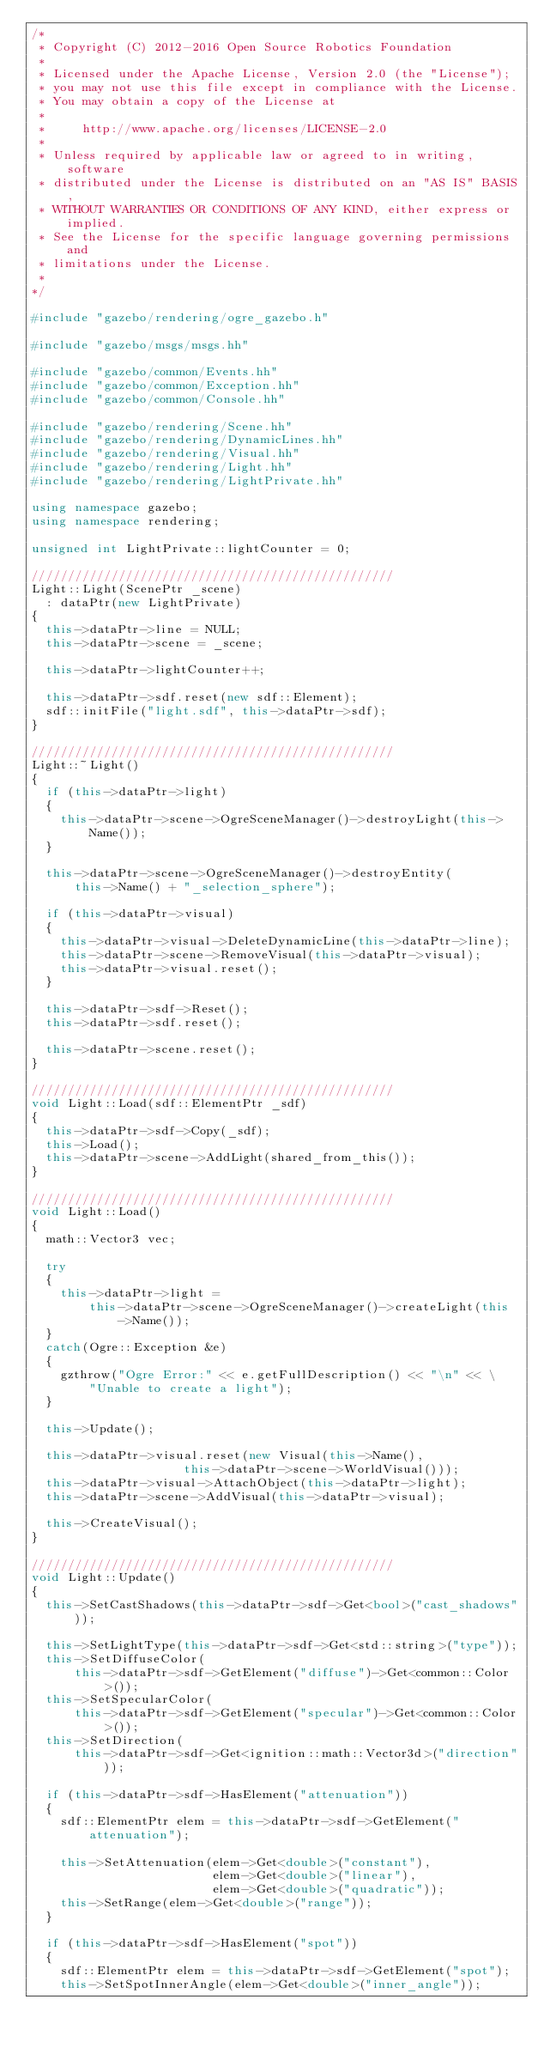Convert code to text. <code><loc_0><loc_0><loc_500><loc_500><_C++_>/*
 * Copyright (C) 2012-2016 Open Source Robotics Foundation
 *
 * Licensed under the Apache License, Version 2.0 (the "License");
 * you may not use this file except in compliance with the License.
 * You may obtain a copy of the License at
 *
 *     http://www.apache.org/licenses/LICENSE-2.0
 *
 * Unless required by applicable law or agreed to in writing, software
 * distributed under the License is distributed on an "AS IS" BASIS,
 * WITHOUT WARRANTIES OR CONDITIONS OF ANY KIND, either express or implied.
 * See the License for the specific language governing permissions and
 * limitations under the License.
 *
*/

#include "gazebo/rendering/ogre_gazebo.h"

#include "gazebo/msgs/msgs.hh"

#include "gazebo/common/Events.hh"
#include "gazebo/common/Exception.hh"
#include "gazebo/common/Console.hh"

#include "gazebo/rendering/Scene.hh"
#include "gazebo/rendering/DynamicLines.hh"
#include "gazebo/rendering/Visual.hh"
#include "gazebo/rendering/Light.hh"
#include "gazebo/rendering/LightPrivate.hh"

using namespace gazebo;
using namespace rendering;

unsigned int LightPrivate::lightCounter = 0;

//////////////////////////////////////////////////
Light::Light(ScenePtr _scene)
  : dataPtr(new LightPrivate)
{
  this->dataPtr->line = NULL;
  this->dataPtr->scene = _scene;

  this->dataPtr->lightCounter++;

  this->dataPtr->sdf.reset(new sdf::Element);
  sdf::initFile("light.sdf", this->dataPtr->sdf);
}

//////////////////////////////////////////////////
Light::~Light()
{
  if (this->dataPtr->light)
  {
    this->dataPtr->scene->OgreSceneManager()->destroyLight(this->Name());
  }

  this->dataPtr->scene->OgreSceneManager()->destroyEntity(
      this->Name() + "_selection_sphere");

  if (this->dataPtr->visual)
  {
    this->dataPtr->visual->DeleteDynamicLine(this->dataPtr->line);
    this->dataPtr->scene->RemoveVisual(this->dataPtr->visual);
    this->dataPtr->visual.reset();
  }

  this->dataPtr->sdf->Reset();
  this->dataPtr->sdf.reset();

  this->dataPtr->scene.reset();
}

//////////////////////////////////////////////////
void Light::Load(sdf::ElementPtr _sdf)
{
  this->dataPtr->sdf->Copy(_sdf);
  this->Load();
  this->dataPtr->scene->AddLight(shared_from_this());
}

//////////////////////////////////////////////////
void Light::Load()
{
  math::Vector3 vec;

  try
  {
    this->dataPtr->light =
        this->dataPtr->scene->OgreSceneManager()->createLight(this->Name());
  }
  catch(Ogre::Exception &e)
  {
    gzthrow("Ogre Error:" << e.getFullDescription() << "\n" << \
        "Unable to create a light");
  }

  this->Update();

  this->dataPtr->visual.reset(new Visual(this->Name(),
                     this->dataPtr->scene->WorldVisual()));
  this->dataPtr->visual->AttachObject(this->dataPtr->light);
  this->dataPtr->scene->AddVisual(this->dataPtr->visual);

  this->CreateVisual();
}

//////////////////////////////////////////////////
void Light::Update()
{
  this->SetCastShadows(this->dataPtr->sdf->Get<bool>("cast_shadows"));

  this->SetLightType(this->dataPtr->sdf->Get<std::string>("type"));
  this->SetDiffuseColor(
      this->dataPtr->sdf->GetElement("diffuse")->Get<common::Color>());
  this->SetSpecularColor(
      this->dataPtr->sdf->GetElement("specular")->Get<common::Color>());
  this->SetDirection(
      this->dataPtr->sdf->Get<ignition::math::Vector3d>("direction"));

  if (this->dataPtr->sdf->HasElement("attenuation"))
  {
    sdf::ElementPtr elem = this->dataPtr->sdf->GetElement("attenuation");

    this->SetAttenuation(elem->Get<double>("constant"),
                         elem->Get<double>("linear"),
                         elem->Get<double>("quadratic"));
    this->SetRange(elem->Get<double>("range"));
  }

  if (this->dataPtr->sdf->HasElement("spot"))
  {
    sdf::ElementPtr elem = this->dataPtr->sdf->GetElement("spot");
    this->SetSpotInnerAngle(elem->Get<double>("inner_angle"));</code> 